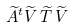Convert formula to latex. <formula><loc_0><loc_0><loc_500><loc_500>\widetilde { A } ^ { t } { \widetilde { V } } \, \widetilde { T } \, { \widetilde { V } }</formula> 